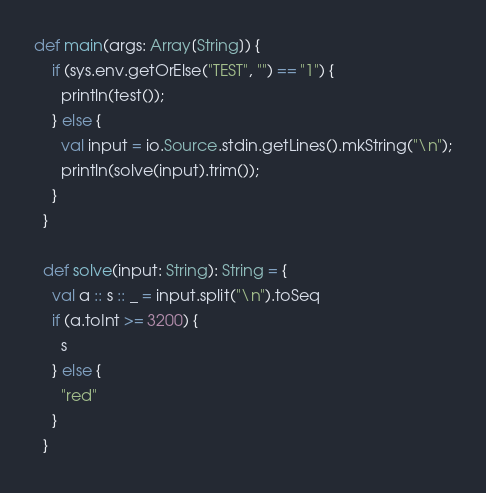Convert code to text. <code><loc_0><loc_0><loc_500><loc_500><_Scala_>def main(args: Array[String]) {
    if (sys.env.getOrElse("TEST", "") == "1") {
      println(test());
    } else {
      val input = io.Source.stdin.getLines().mkString("\n");
      println(solve(input).trim());
    }
  }

  def solve(input: String): String = {
    val a :: s :: _ = input.split("\n").toSeq
    if (a.toInt >= 3200) {
      s
    } else {
      "red"
    }
  }</code> 